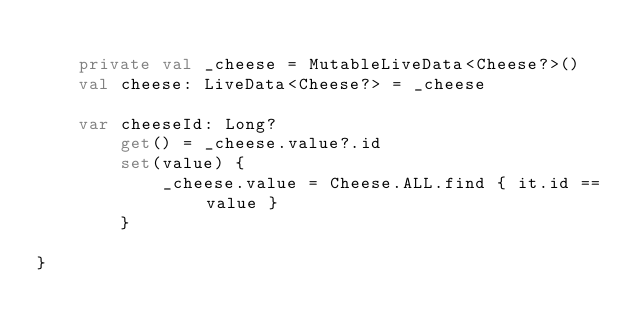Convert code to text. <code><loc_0><loc_0><loc_500><loc_500><_Kotlin_>
    private val _cheese = MutableLiveData<Cheese?>()
    val cheese: LiveData<Cheese?> = _cheese

    var cheeseId: Long?
        get() = _cheese.value?.id
        set(value) {
            _cheese.value = Cheese.ALL.find { it.id == value }
        }

}
</code> 